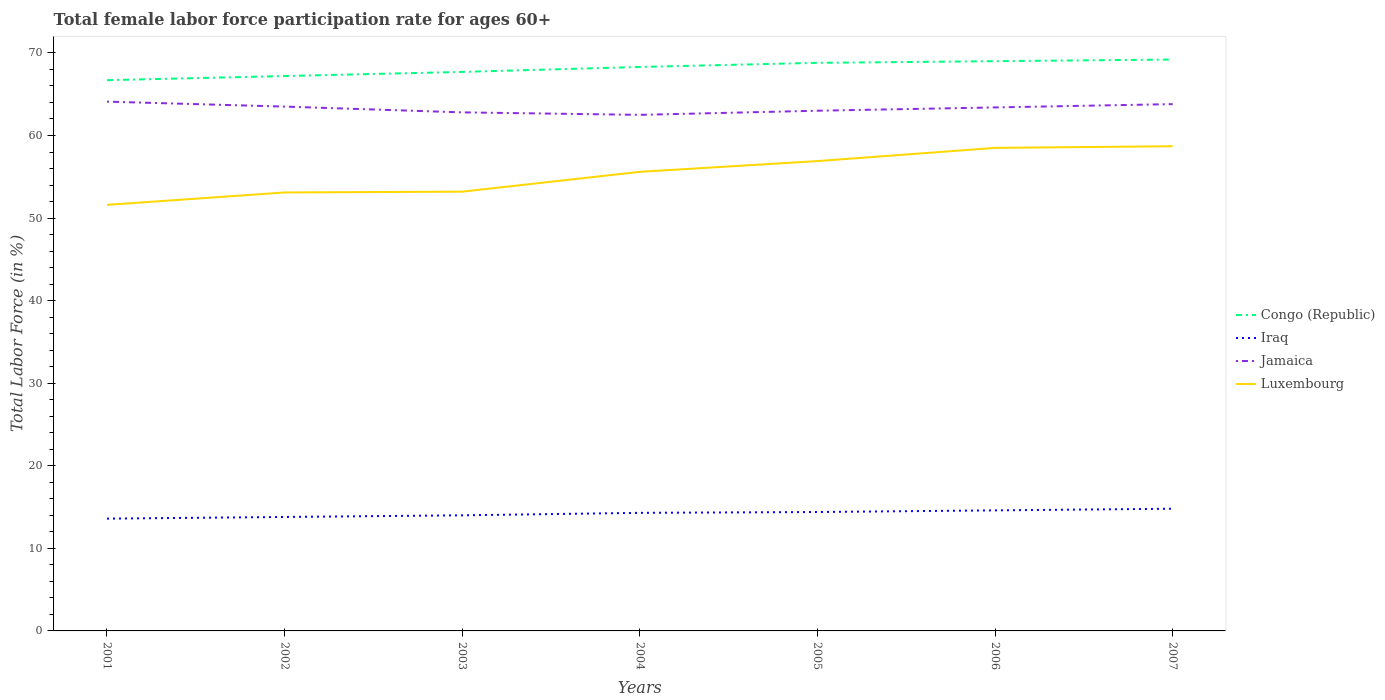How many different coloured lines are there?
Your answer should be very brief. 4. Is the number of lines equal to the number of legend labels?
Offer a very short reply. Yes. Across all years, what is the maximum female labor force participation rate in Congo (Republic)?
Provide a succinct answer. 66.7. In which year was the female labor force participation rate in Iraq maximum?
Your answer should be very brief. 2001. What is the total female labor force participation rate in Luxembourg in the graph?
Your response must be concise. -5.3. What is the difference between the highest and the second highest female labor force participation rate in Iraq?
Your answer should be very brief. 1.2. How many years are there in the graph?
Keep it short and to the point. 7. Are the values on the major ticks of Y-axis written in scientific E-notation?
Your answer should be compact. No. Does the graph contain grids?
Offer a terse response. No. Where does the legend appear in the graph?
Your response must be concise. Center right. How many legend labels are there?
Provide a short and direct response. 4. How are the legend labels stacked?
Make the answer very short. Vertical. What is the title of the graph?
Provide a short and direct response. Total female labor force participation rate for ages 60+. Does "Fragile and conflict affected situations" appear as one of the legend labels in the graph?
Provide a succinct answer. No. What is the label or title of the X-axis?
Ensure brevity in your answer.  Years. What is the Total Labor Force (in %) of Congo (Republic) in 2001?
Your response must be concise. 66.7. What is the Total Labor Force (in %) of Iraq in 2001?
Your response must be concise. 13.6. What is the Total Labor Force (in %) in Jamaica in 2001?
Provide a short and direct response. 64.1. What is the Total Labor Force (in %) in Luxembourg in 2001?
Your answer should be compact. 51.6. What is the Total Labor Force (in %) of Congo (Republic) in 2002?
Ensure brevity in your answer.  67.2. What is the Total Labor Force (in %) of Iraq in 2002?
Make the answer very short. 13.8. What is the Total Labor Force (in %) of Jamaica in 2002?
Offer a very short reply. 63.5. What is the Total Labor Force (in %) of Luxembourg in 2002?
Your answer should be very brief. 53.1. What is the Total Labor Force (in %) of Congo (Republic) in 2003?
Provide a succinct answer. 67.7. What is the Total Labor Force (in %) of Jamaica in 2003?
Give a very brief answer. 62.8. What is the Total Labor Force (in %) in Luxembourg in 2003?
Make the answer very short. 53.2. What is the Total Labor Force (in %) of Congo (Republic) in 2004?
Your answer should be compact. 68.3. What is the Total Labor Force (in %) of Iraq in 2004?
Your answer should be very brief. 14.3. What is the Total Labor Force (in %) in Jamaica in 2004?
Your answer should be very brief. 62.5. What is the Total Labor Force (in %) of Luxembourg in 2004?
Your answer should be compact. 55.6. What is the Total Labor Force (in %) in Congo (Republic) in 2005?
Make the answer very short. 68.8. What is the Total Labor Force (in %) in Iraq in 2005?
Your response must be concise. 14.4. What is the Total Labor Force (in %) of Luxembourg in 2005?
Your response must be concise. 56.9. What is the Total Labor Force (in %) in Iraq in 2006?
Your response must be concise. 14.6. What is the Total Labor Force (in %) of Jamaica in 2006?
Give a very brief answer. 63.4. What is the Total Labor Force (in %) of Luxembourg in 2006?
Make the answer very short. 58.5. What is the Total Labor Force (in %) in Congo (Republic) in 2007?
Make the answer very short. 69.2. What is the Total Labor Force (in %) in Iraq in 2007?
Provide a short and direct response. 14.8. What is the Total Labor Force (in %) of Jamaica in 2007?
Provide a short and direct response. 63.8. What is the Total Labor Force (in %) in Luxembourg in 2007?
Your response must be concise. 58.7. Across all years, what is the maximum Total Labor Force (in %) of Congo (Republic)?
Provide a succinct answer. 69.2. Across all years, what is the maximum Total Labor Force (in %) in Iraq?
Your answer should be very brief. 14.8. Across all years, what is the maximum Total Labor Force (in %) of Jamaica?
Provide a short and direct response. 64.1. Across all years, what is the maximum Total Labor Force (in %) in Luxembourg?
Give a very brief answer. 58.7. Across all years, what is the minimum Total Labor Force (in %) of Congo (Republic)?
Provide a short and direct response. 66.7. Across all years, what is the minimum Total Labor Force (in %) of Iraq?
Your response must be concise. 13.6. Across all years, what is the minimum Total Labor Force (in %) in Jamaica?
Keep it short and to the point. 62.5. Across all years, what is the minimum Total Labor Force (in %) of Luxembourg?
Provide a succinct answer. 51.6. What is the total Total Labor Force (in %) of Congo (Republic) in the graph?
Make the answer very short. 476.9. What is the total Total Labor Force (in %) in Iraq in the graph?
Provide a short and direct response. 99.5. What is the total Total Labor Force (in %) in Jamaica in the graph?
Make the answer very short. 443.1. What is the total Total Labor Force (in %) in Luxembourg in the graph?
Your answer should be compact. 387.6. What is the difference between the Total Labor Force (in %) of Congo (Republic) in 2001 and that in 2002?
Your response must be concise. -0.5. What is the difference between the Total Labor Force (in %) in Jamaica in 2001 and that in 2002?
Offer a terse response. 0.6. What is the difference between the Total Labor Force (in %) of Luxembourg in 2001 and that in 2002?
Give a very brief answer. -1.5. What is the difference between the Total Labor Force (in %) of Congo (Republic) in 2001 and that in 2003?
Provide a succinct answer. -1. What is the difference between the Total Labor Force (in %) of Jamaica in 2001 and that in 2003?
Provide a succinct answer. 1.3. What is the difference between the Total Labor Force (in %) of Iraq in 2001 and that in 2004?
Make the answer very short. -0.7. What is the difference between the Total Labor Force (in %) of Congo (Republic) in 2001 and that in 2005?
Offer a terse response. -2.1. What is the difference between the Total Labor Force (in %) of Iraq in 2001 and that in 2006?
Ensure brevity in your answer.  -1. What is the difference between the Total Labor Force (in %) of Luxembourg in 2001 and that in 2006?
Provide a short and direct response. -6.9. What is the difference between the Total Labor Force (in %) of Congo (Republic) in 2001 and that in 2007?
Offer a very short reply. -2.5. What is the difference between the Total Labor Force (in %) in Iraq in 2001 and that in 2007?
Offer a very short reply. -1.2. What is the difference between the Total Labor Force (in %) of Jamaica in 2001 and that in 2007?
Your answer should be very brief. 0.3. What is the difference between the Total Labor Force (in %) in Congo (Republic) in 2002 and that in 2003?
Make the answer very short. -0.5. What is the difference between the Total Labor Force (in %) of Jamaica in 2002 and that in 2003?
Provide a succinct answer. 0.7. What is the difference between the Total Labor Force (in %) of Iraq in 2002 and that in 2004?
Your answer should be very brief. -0.5. What is the difference between the Total Labor Force (in %) in Jamaica in 2002 and that in 2005?
Keep it short and to the point. 0.5. What is the difference between the Total Labor Force (in %) of Luxembourg in 2002 and that in 2005?
Your response must be concise. -3.8. What is the difference between the Total Labor Force (in %) in Iraq in 2002 and that in 2006?
Make the answer very short. -0.8. What is the difference between the Total Labor Force (in %) of Jamaica in 2002 and that in 2007?
Keep it short and to the point. -0.3. What is the difference between the Total Labor Force (in %) in Luxembourg in 2002 and that in 2007?
Keep it short and to the point. -5.6. What is the difference between the Total Labor Force (in %) in Congo (Republic) in 2003 and that in 2005?
Offer a terse response. -1.1. What is the difference between the Total Labor Force (in %) in Jamaica in 2003 and that in 2005?
Make the answer very short. -0.2. What is the difference between the Total Labor Force (in %) of Iraq in 2003 and that in 2006?
Ensure brevity in your answer.  -0.6. What is the difference between the Total Labor Force (in %) in Luxembourg in 2003 and that in 2006?
Provide a short and direct response. -5.3. What is the difference between the Total Labor Force (in %) of Congo (Republic) in 2003 and that in 2007?
Your answer should be very brief. -1.5. What is the difference between the Total Labor Force (in %) in Jamaica in 2003 and that in 2007?
Your response must be concise. -1. What is the difference between the Total Labor Force (in %) in Luxembourg in 2003 and that in 2007?
Provide a succinct answer. -5.5. What is the difference between the Total Labor Force (in %) in Congo (Republic) in 2004 and that in 2005?
Keep it short and to the point. -0.5. What is the difference between the Total Labor Force (in %) in Iraq in 2004 and that in 2005?
Give a very brief answer. -0.1. What is the difference between the Total Labor Force (in %) of Jamaica in 2004 and that in 2005?
Your answer should be very brief. -0.5. What is the difference between the Total Labor Force (in %) of Congo (Republic) in 2004 and that in 2006?
Make the answer very short. -0.7. What is the difference between the Total Labor Force (in %) in Luxembourg in 2004 and that in 2006?
Offer a terse response. -2.9. What is the difference between the Total Labor Force (in %) of Congo (Republic) in 2004 and that in 2007?
Make the answer very short. -0.9. What is the difference between the Total Labor Force (in %) of Iraq in 2004 and that in 2007?
Your response must be concise. -0.5. What is the difference between the Total Labor Force (in %) in Jamaica in 2004 and that in 2007?
Provide a short and direct response. -1.3. What is the difference between the Total Labor Force (in %) of Luxembourg in 2004 and that in 2007?
Offer a very short reply. -3.1. What is the difference between the Total Labor Force (in %) of Congo (Republic) in 2005 and that in 2007?
Make the answer very short. -0.4. What is the difference between the Total Labor Force (in %) of Jamaica in 2005 and that in 2007?
Give a very brief answer. -0.8. What is the difference between the Total Labor Force (in %) of Luxembourg in 2005 and that in 2007?
Your response must be concise. -1.8. What is the difference between the Total Labor Force (in %) of Congo (Republic) in 2006 and that in 2007?
Your answer should be very brief. -0.2. What is the difference between the Total Labor Force (in %) of Congo (Republic) in 2001 and the Total Labor Force (in %) of Iraq in 2002?
Give a very brief answer. 52.9. What is the difference between the Total Labor Force (in %) in Iraq in 2001 and the Total Labor Force (in %) in Jamaica in 2002?
Your answer should be compact. -49.9. What is the difference between the Total Labor Force (in %) of Iraq in 2001 and the Total Labor Force (in %) of Luxembourg in 2002?
Ensure brevity in your answer.  -39.5. What is the difference between the Total Labor Force (in %) in Congo (Republic) in 2001 and the Total Labor Force (in %) in Iraq in 2003?
Provide a short and direct response. 52.7. What is the difference between the Total Labor Force (in %) of Congo (Republic) in 2001 and the Total Labor Force (in %) of Luxembourg in 2003?
Make the answer very short. 13.5. What is the difference between the Total Labor Force (in %) in Iraq in 2001 and the Total Labor Force (in %) in Jamaica in 2003?
Your response must be concise. -49.2. What is the difference between the Total Labor Force (in %) of Iraq in 2001 and the Total Labor Force (in %) of Luxembourg in 2003?
Your answer should be very brief. -39.6. What is the difference between the Total Labor Force (in %) in Congo (Republic) in 2001 and the Total Labor Force (in %) in Iraq in 2004?
Offer a very short reply. 52.4. What is the difference between the Total Labor Force (in %) of Congo (Republic) in 2001 and the Total Labor Force (in %) of Luxembourg in 2004?
Keep it short and to the point. 11.1. What is the difference between the Total Labor Force (in %) in Iraq in 2001 and the Total Labor Force (in %) in Jamaica in 2004?
Give a very brief answer. -48.9. What is the difference between the Total Labor Force (in %) of Iraq in 2001 and the Total Labor Force (in %) of Luxembourg in 2004?
Provide a succinct answer. -42. What is the difference between the Total Labor Force (in %) in Congo (Republic) in 2001 and the Total Labor Force (in %) in Iraq in 2005?
Your answer should be compact. 52.3. What is the difference between the Total Labor Force (in %) in Congo (Republic) in 2001 and the Total Labor Force (in %) in Jamaica in 2005?
Make the answer very short. 3.7. What is the difference between the Total Labor Force (in %) of Congo (Republic) in 2001 and the Total Labor Force (in %) of Luxembourg in 2005?
Give a very brief answer. 9.8. What is the difference between the Total Labor Force (in %) in Iraq in 2001 and the Total Labor Force (in %) in Jamaica in 2005?
Your answer should be very brief. -49.4. What is the difference between the Total Labor Force (in %) of Iraq in 2001 and the Total Labor Force (in %) of Luxembourg in 2005?
Give a very brief answer. -43.3. What is the difference between the Total Labor Force (in %) in Congo (Republic) in 2001 and the Total Labor Force (in %) in Iraq in 2006?
Offer a terse response. 52.1. What is the difference between the Total Labor Force (in %) in Iraq in 2001 and the Total Labor Force (in %) in Jamaica in 2006?
Offer a very short reply. -49.8. What is the difference between the Total Labor Force (in %) in Iraq in 2001 and the Total Labor Force (in %) in Luxembourg in 2006?
Provide a short and direct response. -44.9. What is the difference between the Total Labor Force (in %) of Congo (Republic) in 2001 and the Total Labor Force (in %) of Iraq in 2007?
Offer a terse response. 51.9. What is the difference between the Total Labor Force (in %) of Congo (Republic) in 2001 and the Total Labor Force (in %) of Luxembourg in 2007?
Provide a succinct answer. 8. What is the difference between the Total Labor Force (in %) of Iraq in 2001 and the Total Labor Force (in %) of Jamaica in 2007?
Offer a terse response. -50.2. What is the difference between the Total Labor Force (in %) in Iraq in 2001 and the Total Labor Force (in %) in Luxembourg in 2007?
Keep it short and to the point. -45.1. What is the difference between the Total Labor Force (in %) of Jamaica in 2001 and the Total Labor Force (in %) of Luxembourg in 2007?
Provide a succinct answer. 5.4. What is the difference between the Total Labor Force (in %) in Congo (Republic) in 2002 and the Total Labor Force (in %) in Iraq in 2003?
Offer a terse response. 53.2. What is the difference between the Total Labor Force (in %) in Congo (Republic) in 2002 and the Total Labor Force (in %) in Luxembourg in 2003?
Your answer should be very brief. 14. What is the difference between the Total Labor Force (in %) in Iraq in 2002 and the Total Labor Force (in %) in Jamaica in 2003?
Make the answer very short. -49. What is the difference between the Total Labor Force (in %) of Iraq in 2002 and the Total Labor Force (in %) of Luxembourg in 2003?
Make the answer very short. -39.4. What is the difference between the Total Labor Force (in %) in Jamaica in 2002 and the Total Labor Force (in %) in Luxembourg in 2003?
Make the answer very short. 10.3. What is the difference between the Total Labor Force (in %) of Congo (Republic) in 2002 and the Total Labor Force (in %) of Iraq in 2004?
Your response must be concise. 52.9. What is the difference between the Total Labor Force (in %) of Congo (Republic) in 2002 and the Total Labor Force (in %) of Jamaica in 2004?
Your answer should be very brief. 4.7. What is the difference between the Total Labor Force (in %) of Congo (Republic) in 2002 and the Total Labor Force (in %) of Luxembourg in 2004?
Offer a terse response. 11.6. What is the difference between the Total Labor Force (in %) of Iraq in 2002 and the Total Labor Force (in %) of Jamaica in 2004?
Ensure brevity in your answer.  -48.7. What is the difference between the Total Labor Force (in %) in Iraq in 2002 and the Total Labor Force (in %) in Luxembourg in 2004?
Give a very brief answer. -41.8. What is the difference between the Total Labor Force (in %) of Congo (Republic) in 2002 and the Total Labor Force (in %) of Iraq in 2005?
Offer a terse response. 52.8. What is the difference between the Total Labor Force (in %) of Iraq in 2002 and the Total Labor Force (in %) of Jamaica in 2005?
Offer a very short reply. -49.2. What is the difference between the Total Labor Force (in %) of Iraq in 2002 and the Total Labor Force (in %) of Luxembourg in 2005?
Give a very brief answer. -43.1. What is the difference between the Total Labor Force (in %) in Congo (Republic) in 2002 and the Total Labor Force (in %) in Iraq in 2006?
Your answer should be very brief. 52.6. What is the difference between the Total Labor Force (in %) of Congo (Republic) in 2002 and the Total Labor Force (in %) of Luxembourg in 2006?
Give a very brief answer. 8.7. What is the difference between the Total Labor Force (in %) of Iraq in 2002 and the Total Labor Force (in %) of Jamaica in 2006?
Give a very brief answer. -49.6. What is the difference between the Total Labor Force (in %) in Iraq in 2002 and the Total Labor Force (in %) in Luxembourg in 2006?
Offer a terse response. -44.7. What is the difference between the Total Labor Force (in %) in Jamaica in 2002 and the Total Labor Force (in %) in Luxembourg in 2006?
Make the answer very short. 5. What is the difference between the Total Labor Force (in %) in Congo (Republic) in 2002 and the Total Labor Force (in %) in Iraq in 2007?
Give a very brief answer. 52.4. What is the difference between the Total Labor Force (in %) in Congo (Republic) in 2002 and the Total Labor Force (in %) in Jamaica in 2007?
Your answer should be compact. 3.4. What is the difference between the Total Labor Force (in %) in Iraq in 2002 and the Total Labor Force (in %) in Jamaica in 2007?
Give a very brief answer. -50. What is the difference between the Total Labor Force (in %) in Iraq in 2002 and the Total Labor Force (in %) in Luxembourg in 2007?
Provide a succinct answer. -44.9. What is the difference between the Total Labor Force (in %) of Congo (Republic) in 2003 and the Total Labor Force (in %) of Iraq in 2004?
Give a very brief answer. 53.4. What is the difference between the Total Labor Force (in %) in Congo (Republic) in 2003 and the Total Labor Force (in %) in Jamaica in 2004?
Your answer should be compact. 5.2. What is the difference between the Total Labor Force (in %) of Iraq in 2003 and the Total Labor Force (in %) of Jamaica in 2004?
Your answer should be very brief. -48.5. What is the difference between the Total Labor Force (in %) of Iraq in 2003 and the Total Labor Force (in %) of Luxembourg in 2004?
Your response must be concise. -41.6. What is the difference between the Total Labor Force (in %) of Congo (Republic) in 2003 and the Total Labor Force (in %) of Iraq in 2005?
Give a very brief answer. 53.3. What is the difference between the Total Labor Force (in %) of Iraq in 2003 and the Total Labor Force (in %) of Jamaica in 2005?
Make the answer very short. -49. What is the difference between the Total Labor Force (in %) in Iraq in 2003 and the Total Labor Force (in %) in Luxembourg in 2005?
Your answer should be very brief. -42.9. What is the difference between the Total Labor Force (in %) in Congo (Republic) in 2003 and the Total Labor Force (in %) in Iraq in 2006?
Offer a terse response. 53.1. What is the difference between the Total Labor Force (in %) in Congo (Republic) in 2003 and the Total Labor Force (in %) in Jamaica in 2006?
Your answer should be compact. 4.3. What is the difference between the Total Labor Force (in %) in Congo (Republic) in 2003 and the Total Labor Force (in %) in Luxembourg in 2006?
Offer a very short reply. 9.2. What is the difference between the Total Labor Force (in %) in Iraq in 2003 and the Total Labor Force (in %) in Jamaica in 2006?
Offer a terse response. -49.4. What is the difference between the Total Labor Force (in %) of Iraq in 2003 and the Total Labor Force (in %) of Luxembourg in 2006?
Your answer should be compact. -44.5. What is the difference between the Total Labor Force (in %) of Jamaica in 2003 and the Total Labor Force (in %) of Luxembourg in 2006?
Make the answer very short. 4.3. What is the difference between the Total Labor Force (in %) in Congo (Republic) in 2003 and the Total Labor Force (in %) in Iraq in 2007?
Your answer should be very brief. 52.9. What is the difference between the Total Labor Force (in %) in Congo (Republic) in 2003 and the Total Labor Force (in %) in Jamaica in 2007?
Ensure brevity in your answer.  3.9. What is the difference between the Total Labor Force (in %) of Congo (Republic) in 2003 and the Total Labor Force (in %) of Luxembourg in 2007?
Offer a very short reply. 9. What is the difference between the Total Labor Force (in %) in Iraq in 2003 and the Total Labor Force (in %) in Jamaica in 2007?
Your answer should be compact. -49.8. What is the difference between the Total Labor Force (in %) in Iraq in 2003 and the Total Labor Force (in %) in Luxembourg in 2007?
Make the answer very short. -44.7. What is the difference between the Total Labor Force (in %) of Jamaica in 2003 and the Total Labor Force (in %) of Luxembourg in 2007?
Provide a short and direct response. 4.1. What is the difference between the Total Labor Force (in %) in Congo (Republic) in 2004 and the Total Labor Force (in %) in Iraq in 2005?
Your response must be concise. 53.9. What is the difference between the Total Labor Force (in %) in Congo (Republic) in 2004 and the Total Labor Force (in %) in Jamaica in 2005?
Your answer should be compact. 5.3. What is the difference between the Total Labor Force (in %) of Iraq in 2004 and the Total Labor Force (in %) of Jamaica in 2005?
Ensure brevity in your answer.  -48.7. What is the difference between the Total Labor Force (in %) of Iraq in 2004 and the Total Labor Force (in %) of Luxembourg in 2005?
Provide a succinct answer. -42.6. What is the difference between the Total Labor Force (in %) in Congo (Republic) in 2004 and the Total Labor Force (in %) in Iraq in 2006?
Your answer should be very brief. 53.7. What is the difference between the Total Labor Force (in %) in Congo (Republic) in 2004 and the Total Labor Force (in %) in Jamaica in 2006?
Offer a very short reply. 4.9. What is the difference between the Total Labor Force (in %) in Iraq in 2004 and the Total Labor Force (in %) in Jamaica in 2006?
Provide a succinct answer. -49.1. What is the difference between the Total Labor Force (in %) of Iraq in 2004 and the Total Labor Force (in %) of Luxembourg in 2006?
Your response must be concise. -44.2. What is the difference between the Total Labor Force (in %) of Congo (Republic) in 2004 and the Total Labor Force (in %) of Iraq in 2007?
Your answer should be compact. 53.5. What is the difference between the Total Labor Force (in %) in Congo (Republic) in 2004 and the Total Labor Force (in %) in Jamaica in 2007?
Keep it short and to the point. 4.5. What is the difference between the Total Labor Force (in %) of Congo (Republic) in 2004 and the Total Labor Force (in %) of Luxembourg in 2007?
Provide a succinct answer. 9.6. What is the difference between the Total Labor Force (in %) of Iraq in 2004 and the Total Labor Force (in %) of Jamaica in 2007?
Offer a very short reply. -49.5. What is the difference between the Total Labor Force (in %) of Iraq in 2004 and the Total Labor Force (in %) of Luxembourg in 2007?
Ensure brevity in your answer.  -44.4. What is the difference between the Total Labor Force (in %) in Jamaica in 2004 and the Total Labor Force (in %) in Luxembourg in 2007?
Provide a short and direct response. 3.8. What is the difference between the Total Labor Force (in %) of Congo (Republic) in 2005 and the Total Labor Force (in %) of Iraq in 2006?
Give a very brief answer. 54.2. What is the difference between the Total Labor Force (in %) in Congo (Republic) in 2005 and the Total Labor Force (in %) in Jamaica in 2006?
Your answer should be very brief. 5.4. What is the difference between the Total Labor Force (in %) in Congo (Republic) in 2005 and the Total Labor Force (in %) in Luxembourg in 2006?
Your response must be concise. 10.3. What is the difference between the Total Labor Force (in %) in Iraq in 2005 and the Total Labor Force (in %) in Jamaica in 2006?
Provide a succinct answer. -49. What is the difference between the Total Labor Force (in %) in Iraq in 2005 and the Total Labor Force (in %) in Luxembourg in 2006?
Ensure brevity in your answer.  -44.1. What is the difference between the Total Labor Force (in %) in Congo (Republic) in 2005 and the Total Labor Force (in %) in Jamaica in 2007?
Make the answer very short. 5. What is the difference between the Total Labor Force (in %) in Iraq in 2005 and the Total Labor Force (in %) in Jamaica in 2007?
Keep it short and to the point. -49.4. What is the difference between the Total Labor Force (in %) in Iraq in 2005 and the Total Labor Force (in %) in Luxembourg in 2007?
Offer a terse response. -44.3. What is the difference between the Total Labor Force (in %) of Congo (Republic) in 2006 and the Total Labor Force (in %) of Iraq in 2007?
Keep it short and to the point. 54.2. What is the difference between the Total Labor Force (in %) in Iraq in 2006 and the Total Labor Force (in %) in Jamaica in 2007?
Give a very brief answer. -49.2. What is the difference between the Total Labor Force (in %) of Iraq in 2006 and the Total Labor Force (in %) of Luxembourg in 2007?
Give a very brief answer. -44.1. What is the difference between the Total Labor Force (in %) in Jamaica in 2006 and the Total Labor Force (in %) in Luxembourg in 2007?
Your answer should be compact. 4.7. What is the average Total Labor Force (in %) in Congo (Republic) per year?
Offer a terse response. 68.13. What is the average Total Labor Force (in %) in Iraq per year?
Your answer should be compact. 14.21. What is the average Total Labor Force (in %) in Jamaica per year?
Keep it short and to the point. 63.3. What is the average Total Labor Force (in %) in Luxembourg per year?
Provide a short and direct response. 55.37. In the year 2001, what is the difference between the Total Labor Force (in %) of Congo (Republic) and Total Labor Force (in %) of Iraq?
Provide a succinct answer. 53.1. In the year 2001, what is the difference between the Total Labor Force (in %) of Congo (Republic) and Total Labor Force (in %) of Luxembourg?
Keep it short and to the point. 15.1. In the year 2001, what is the difference between the Total Labor Force (in %) of Iraq and Total Labor Force (in %) of Jamaica?
Make the answer very short. -50.5. In the year 2001, what is the difference between the Total Labor Force (in %) of Iraq and Total Labor Force (in %) of Luxembourg?
Provide a short and direct response. -38. In the year 2001, what is the difference between the Total Labor Force (in %) in Jamaica and Total Labor Force (in %) in Luxembourg?
Your answer should be compact. 12.5. In the year 2002, what is the difference between the Total Labor Force (in %) in Congo (Republic) and Total Labor Force (in %) in Iraq?
Provide a short and direct response. 53.4. In the year 2002, what is the difference between the Total Labor Force (in %) of Iraq and Total Labor Force (in %) of Jamaica?
Your response must be concise. -49.7. In the year 2002, what is the difference between the Total Labor Force (in %) of Iraq and Total Labor Force (in %) of Luxembourg?
Offer a terse response. -39.3. In the year 2002, what is the difference between the Total Labor Force (in %) in Jamaica and Total Labor Force (in %) in Luxembourg?
Offer a very short reply. 10.4. In the year 2003, what is the difference between the Total Labor Force (in %) of Congo (Republic) and Total Labor Force (in %) of Iraq?
Give a very brief answer. 53.7. In the year 2003, what is the difference between the Total Labor Force (in %) in Congo (Republic) and Total Labor Force (in %) in Jamaica?
Give a very brief answer. 4.9. In the year 2003, what is the difference between the Total Labor Force (in %) in Congo (Republic) and Total Labor Force (in %) in Luxembourg?
Your answer should be compact. 14.5. In the year 2003, what is the difference between the Total Labor Force (in %) of Iraq and Total Labor Force (in %) of Jamaica?
Make the answer very short. -48.8. In the year 2003, what is the difference between the Total Labor Force (in %) of Iraq and Total Labor Force (in %) of Luxembourg?
Your answer should be compact. -39.2. In the year 2004, what is the difference between the Total Labor Force (in %) in Congo (Republic) and Total Labor Force (in %) in Jamaica?
Your answer should be very brief. 5.8. In the year 2004, what is the difference between the Total Labor Force (in %) in Congo (Republic) and Total Labor Force (in %) in Luxembourg?
Offer a very short reply. 12.7. In the year 2004, what is the difference between the Total Labor Force (in %) of Iraq and Total Labor Force (in %) of Jamaica?
Your response must be concise. -48.2. In the year 2004, what is the difference between the Total Labor Force (in %) in Iraq and Total Labor Force (in %) in Luxembourg?
Make the answer very short. -41.3. In the year 2004, what is the difference between the Total Labor Force (in %) of Jamaica and Total Labor Force (in %) of Luxembourg?
Keep it short and to the point. 6.9. In the year 2005, what is the difference between the Total Labor Force (in %) of Congo (Republic) and Total Labor Force (in %) of Iraq?
Your answer should be very brief. 54.4. In the year 2005, what is the difference between the Total Labor Force (in %) in Iraq and Total Labor Force (in %) in Jamaica?
Provide a short and direct response. -48.6. In the year 2005, what is the difference between the Total Labor Force (in %) of Iraq and Total Labor Force (in %) of Luxembourg?
Your response must be concise. -42.5. In the year 2005, what is the difference between the Total Labor Force (in %) in Jamaica and Total Labor Force (in %) in Luxembourg?
Ensure brevity in your answer.  6.1. In the year 2006, what is the difference between the Total Labor Force (in %) of Congo (Republic) and Total Labor Force (in %) of Iraq?
Give a very brief answer. 54.4. In the year 2006, what is the difference between the Total Labor Force (in %) of Congo (Republic) and Total Labor Force (in %) of Jamaica?
Provide a short and direct response. 5.6. In the year 2006, what is the difference between the Total Labor Force (in %) in Congo (Republic) and Total Labor Force (in %) in Luxembourg?
Provide a short and direct response. 10.5. In the year 2006, what is the difference between the Total Labor Force (in %) of Iraq and Total Labor Force (in %) of Jamaica?
Give a very brief answer. -48.8. In the year 2006, what is the difference between the Total Labor Force (in %) in Iraq and Total Labor Force (in %) in Luxembourg?
Your response must be concise. -43.9. In the year 2006, what is the difference between the Total Labor Force (in %) of Jamaica and Total Labor Force (in %) of Luxembourg?
Your answer should be very brief. 4.9. In the year 2007, what is the difference between the Total Labor Force (in %) of Congo (Republic) and Total Labor Force (in %) of Iraq?
Your answer should be compact. 54.4. In the year 2007, what is the difference between the Total Labor Force (in %) in Congo (Republic) and Total Labor Force (in %) in Jamaica?
Offer a terse response. 5.4. In the year 2007, what is the difference between the Total Labor Force (in %) of Iraq and Total Labor Force (in %) of Jamaica?
Provide a succinct answer. -49. In the year 2007, what is the difference between the Total Labor Force (in %) in Iraq and Total Labor Force (in %) in Luxembourg?
Offer a terse response. -43.9. In the year 2007, what is the difference between the Total Labor Force (in %) of Jamaica and Total Labor Force (in %) of Luxembourg?
Offer a very short reply. 5.1. What is the ratio of the Total Labor Force (in %) in Congo (Republic) in 2001 to that in 2002?
Your response must be concise. 0.99. What is the ratio of the Total Labor Force (in %) of Iraq in 2001 to that in 2002?
Offer a terse response. 0.99. What is the ratio of the Total Labor Force (in %) of Jamaica in 2001 to that in 2002?
Ensure brevity in your answer.  1.01. What is the ratio of the Total Labor Force (in %) in Luxembourg in 2001 to that in 2002?
Keep it short and to the point. 0.97. What is the ratio of the Total Labor Force (in %) in Congo (Republic) in 2001 to that in 2003?
Make the answer very short. 0.99. What is the ratio of the Total Labor Force (in %) of Iraq in 2001 to that in 2003?
Your answer should be very brief. 0.97. What is the ratio of the Total Labor Force (in %) of Jamaica in 2001 to that in 2003?
Provide a succinct answer. 1.02. What is the ratio of the Total Labor Force (in %) of Luxembourg in 2001 to that in 2003?
Your answer should be very brief. 0.97. What is the ratio of the Total Labor Force (in %) in Congo (Republic) in 2001 to that in 2004?
Make the answer very short. 0.98. What is the ratio of the Total Labor Force (in %) of Iraq in 2001 to that in 2004?
Keep it short and to the point. 0.95. What is the ratio of the Total Labor Force (in %) of Jamaica in 2001 to that in 2004?
Give a very brief answer. 1.03. What is the ratio of the Total Labor Force (in %) of Luxembourg in 2001 to that in 2004?
Provide a succinct answer. 0.93. What is the ratio of the Total Labor Force (in %) of Congo (Republic) in 2001 to that in 2005?
Provide a succinct answer. 0.97. What is the ratio of the Total Labor Force (in %) of Iraq in 2001 to that in 2005?
Provide a short and direct response. 0.94. What is the ratio of the Total Labor Force (in %) of Jamaica in 2001 to that in 2005?
Your answer should be compact. 1.02. What is the ratio of the Total Labor Force (in %) of Luxembourg in 2001 to that in 2005?
Your answer should be compact. 0.91. What is the ratio of the Total Labor Force (in %) in Congo (Republic) in 2001 to that in 2006?
Provide a succinct answer. 0.97. What is the ratio of the Total Labor Force (in %) of Iraq in 2001 to that in 2006?
Keep it short and to the point. 0.93. What is the ratio of the Total Labor Force (in %) in Jamaica in 2001 to that in 2006?
Your answer should be very brief. 1.01. What is the ratio of the Total Labor Force (in %) in Luxembourg in 2001 to that in 2006?
Ensure brevity in your answer.  0.88. What is the ratio of the Total Labor Force (in %) in Congo (Republic) in 2001 to that in 2007?
Keep it short and to the point. 0.96. What is the ratio of the Total Labor Force (in %) of Iraq in 2001 to that in 2007?
Your response must be concise. 0.92. What is the ratio of the Total Labor Force (in %) in Luxembourg in 2001 to that in 2007?
Your answer should be compact. 0.88. What is the ratio of the Total Labor Force (in %) of Iraq in 2002 to that in 2003?
Provide a succinct answer. 0.99. What is the ratio of the Total Labor Force (in %) of Jamaica in 2002 to that in 2003?
Ensure brevity in your answer.  1.01. What is the ratio of the Total Labor Force (in %) of Congo (Republic) in 2002 to that in 2004?
Provide a short and direct response. 0.98. What is the ratio of the Total Labor Force (in %) in Jamaica in 2002 to that in 2004?
Your response must be concise. 1.02. What is the ratio of the Total Labor Force (in %) of Luxembourg in 2002 to that in 2004?
Give a very brief answer. 0.95. What is the ratio of the Total Labor Force (in %) of Congo (Republic) in 2002 to that in 2005?
Offer a very short reply. 0.98. What is the ratio of the Total Labor Force (in %) in Iraq in 2002 to that in 2005?
Your answer should be very brief. 0.96. What is the ratio of the Total Labor Force (in %) of Jamaica in 2002 to that in 2005?
Give a very brief answer. 1.01. What is the ratio of the Total Labor Force (in %) of Luxembourg in 2002 to that in 2005?
Provide a succinct answer. 0.93. What is the ratio of the Total Labor Force (in %) of Congo (Republic) in 2002 to that in 2006?
Make the answer very short. 0.97. What is the ratio of the Total Labor Force (in %) of Iraq in 2002 to that in 2006?
Make the answer very short. 0.95. What is the ratio of the Total Labor Force (in %) in Luxembourg in 2002 to that in 2006?
Provide a short and direct response. 0.91. What is the ratio of the Total Labor Force (in %) in Congo (Republic) in 2002 to that in 2007?
Give a very brief answer. 0.97. What is the ratio of the Total Labor Force (in %) of Iraq in 2002 to that in 2007?
Ensure brevity in your answer.  0.93. What is the ratio of the Total Labor Force (in %) of Luxembourg in 2002 to that in 2007?
Your answer should be very brief. 0.9. What is the ratio of the Total Labor Force (in %) in Iraq in 2003 to that in 2004?
Provide a short and direct response. 0.98. What is the ratio of the Total Labor Force (in %) in Jamaica in 2003 to that in 2004?
Offer a very short reply. 1. What is the ratio of the Total Labor Force (in %) in Luxembourg in 2003 to that in 2004?
Offer a terse response. 0.96. What is the ratio of the Total Labor Force (in %) of Iraq in 2003 to that in 2005?
Give a very brief answer. 0.97. What is the ratio of the Total Labor Force (in %) of Jamaica in 2003 to that in 2005?
Offer a very short reply. 1. What is the ratio of the Total Labor Force (in %) of Luxembourg in 2003 to that in 2005?
Your answer should be very brief. 0.94. What is the ratio of the Total Labor Force (in %) of Congo (Republic) in 2003 to that in 2006?
Ensure brevity in your answer.  0.98. What is the ratio of the Total Labor Force (in %) in Iraq in 2003 to that in 2006?
Keep it short and to the point. 0.96. What is the ratio of the Total Labor Force (in %) of Jamaica in 2003 to that in 2006?
Your response must be concise. 0.99. What is the ratio of the Total Labor Force (in %) in Luxembourg in 2003 to that in 2006?
Ensure brevity in your answer.  0.91. What is the ratio of the Total Labor Force (in %) in Congo (Republic) in 2003 to that in 2007?
Provide a succinct answer. 0.98. What is the ratio of the Total Labor Force (in %) in Iraq in 2003 to that in 2007?
Keep it short and to the point. 0.95. What is the ratio of the Total Labor Force (in %) in Jamaica in 2003 to that in 2007?
Offer a very short reply. 0.98. What is the ratio of the Total Labor Force (in %) in Luxembourg in 2003 to that in 2007?
Offer a very short reply. 0.91. What is the ratio of the Total Labor Force (in %) of Jamaica in 2004 to that in 2005?
Provide a succinct answer. 0.99. What is the ratio of the Total Labor Force (in %) in Luxembourg in 2004 to that in 2005?
Offer a very short reply. 0.98. What is the ratio of the Total Labor Force (in %) of Iraq in 2004 to that in 2006?
Make the answer very short. 0.98. What is the ratio of the Total Labor Force (in %) in Jamaica in 2004 to that in 2006?
Your answer should be compact. 0.99. What is the ratio of the Total Labor Force (in %) in Luxembourg in 2004 to that in 2006?
Give a very brief answer. 0.95. What is the ratio of the Total Labor Force (in %) in Iraq in 2004 to that in 2007?
Provide a succinct answer. 0.97. What is the ratio of the Total Labor Force (in %) of Jamaica in 2004 to that in 2007?
Ensure brevity in your answer.  0.98. What is the ratio of the Total Labor Force (in %) in Luxembourg in 2004 to that in 2007?
Your answer should be very brief. 0.95. What is the ratio of the Total Labor Force (in %) in Iraq in 2005 to that in 2006?
Provide a short and direct response. 0.99. What is the ratio of the Total Labor Force (in %) in Luxembourg in 2005 to that in 2006?
Offer a terse response. 0.97. What is the ratio of the Total Labor Force (in %) in Jamaica in 2005 to that in 2007?
Your answer should be compact. 0.99. What is the ratio of the Total Labor Force (in %) in Luxembourg in 2005 to that in 2007?
Offer a terse response. 0.97. What is the ratio of the Total Labor Force (in %) in Iraq in 2006 to that in 2007?
Provide a short and direct response. 0.99. What is the ratio of the Total Labor Force (in %) in Luxembourg in 2006 to that in 2007?
Ensure brevity in your answer.  1. What is the difference between the highest and the second highest Total Labor Force (in %) in Luxembourg?
Offer a very short reply. 0.2. 